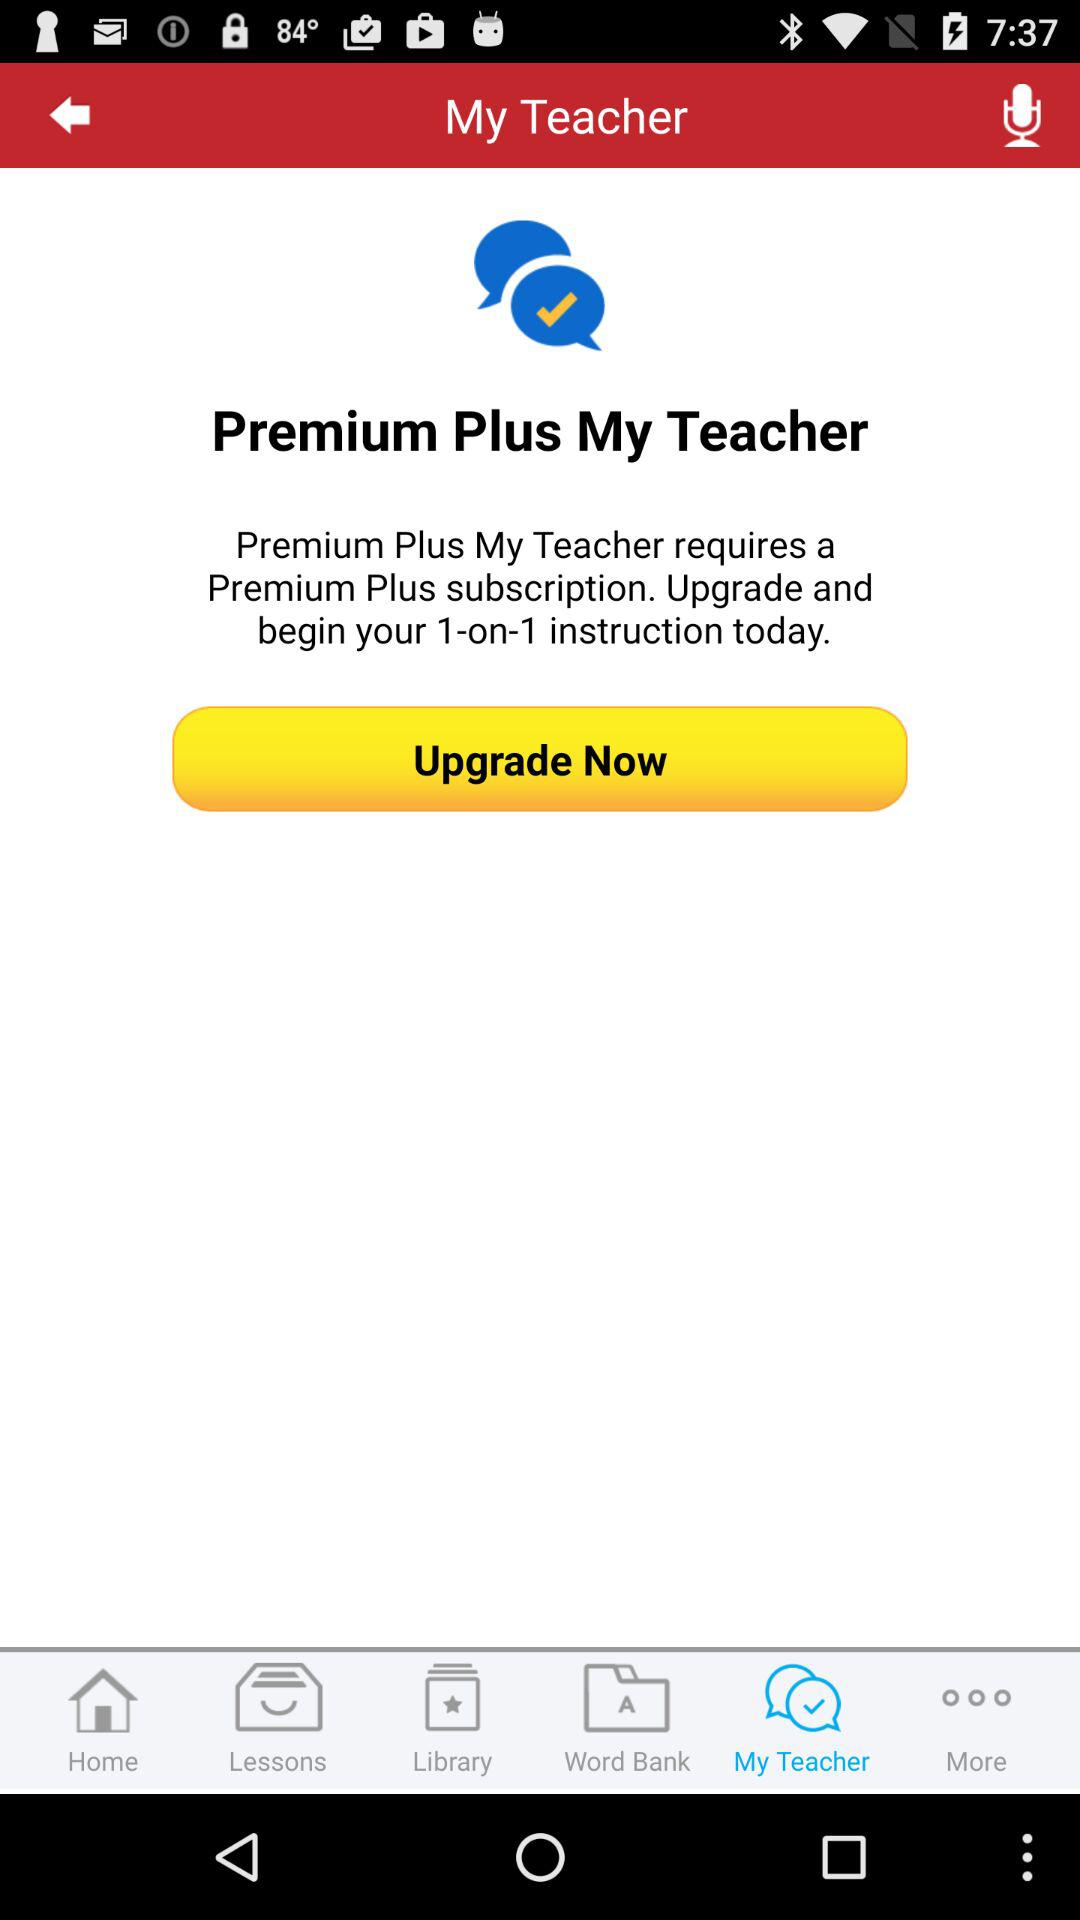What type of subscription is required by "Premium Plus My Teacher"? They require a "Premium Plus" subscription. 